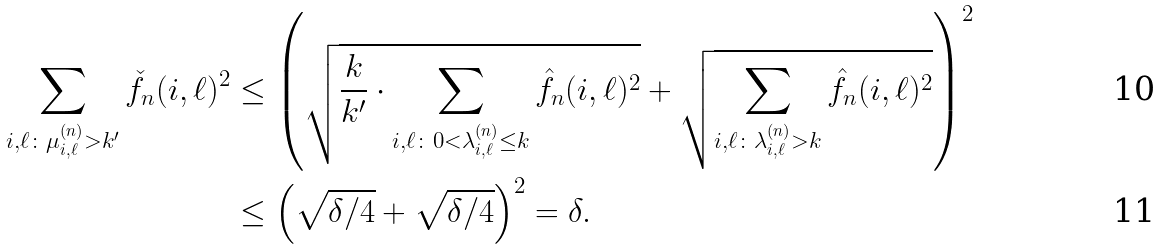<formula> <loc_0><loc_0><loc_500><loc_500>\sum _ { i , \ell \colon \mu _ { i , \ell } ^ { ( n ) } > k ^ { \prime } } \check { f } _ { n } ( i , \ell ) ^ { 2 } & \leq \left ( \sqrt { \frac { k } { k ^ { \prime } } \cdot { \sum _ { i , \ell \colon 0 < \lambda _ { i , \ell } ^ { ( n ) } \leq k } \hat { f } _ { n } ( i , \ell ) ^ { 2 } } } + \sqrt { \sum _ { i , \ell \colon \lambda _ { i , \ell } ^ { ( n ) } > k } \hat { f } _ { n } ( i , \ell ) ^ { 2 } } \right ) ^ { 2 } \\ & \leq \left ( \sqrt { \delta / 4 } + \sqrt { \delta / 4 } \right ) ^ { 2 } = \delta .</formula> 